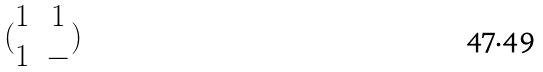Convert formula to latex. <formula><loc_0><loc_0><loc_500><loc_500>( \begin{matrix} 1 & 1 \\ 1 & - \end{matrix} )</formula> 